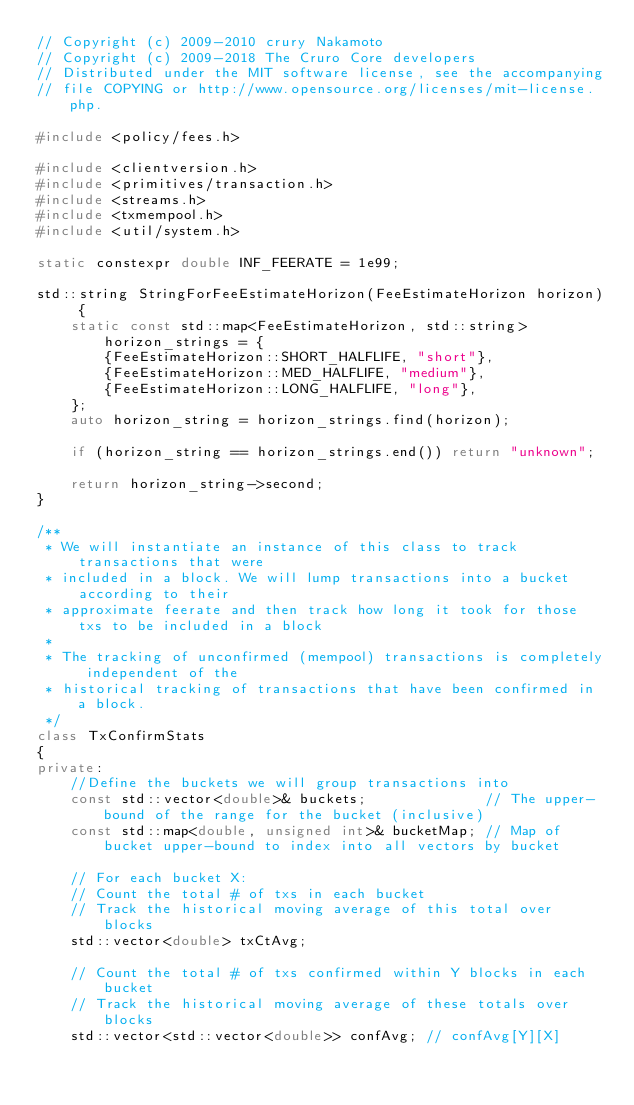<code> <loc_0><loc_0><loc_500><loc_500><_C++_>// Copyright (c) 2009-2010 crury Nakamoto
// Copyright (c) 2009-2018 The Cruro Core developers
// Distributed under the MIT software license, see the accompanying
// file COPYING or http://www.opensource.org/licenses/mit-license.php.

#include <policy/fees.h>

#include <clientversion.h>
#include <primitives/transaction.h>
#include <streams.h>
#include <txmempool.h>
#include <util/system.h>

static constexpr double INF_FEERATE = 1e99;

std::string StringForFeeEstimateHorizon(FeeEstimateHorizon horizon) {
    static const std::map<FeeEstimateHorizon, std::string> horizon_strings = {
        {FeeEstimateHorizon::SHORT_HALFLIFE, "short"},
        {FeeEstimateHorizon::MED_HALFLIFE, "medium"},
        {FeeEstimateHorizon::LONG_HALFLIFE, "long"},
    };
    auto horizon_string = horizon_strings.find(horizon);

    if (horizon_string == horizon_strings.end()) return "unknown";

    return horizon_string->second;
}

/**
 * We will instantiate an instance of this class to track transactions that were
 * included in a block. We will lump transactions into a bucket according to their
 * approximate feerate and then track how long it took for those txs to be included in a block
 *
 * The tracking of unconfirmed (mempool) transactions is completely independent of the
 * historical tracking of transactions that have been confirmed in a block.
 */
class TxConfirmStats
{
private:
    //Define the buckets we will group transactions into
    const std::vector<double>& buckets;              // The upper-bound of the range for the bucket (inclusive)
    const std::map<double, unsigned int>& bucketMap; // Map of bucket upper-bound to index into all vectors by bucket

    // For each bucket X:
    // Count the total # of txs in each bucket
    // Track the historical moving average of this total over blocks
    std::vector<double> txCtAvg;

    // Count the total # of txs confirmed within Y blocks in each bucket
    // Track the historical moving average of these totals over blocks
    std::vector<std::vector<double>> confAvg; // confAvg[Y][X]
</code> 